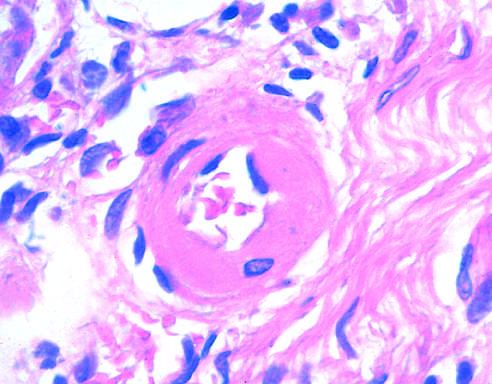s herpes simplex virus and varicella-zoster virus markedly narrowed?
Answer the question using a single word or phrase. No 